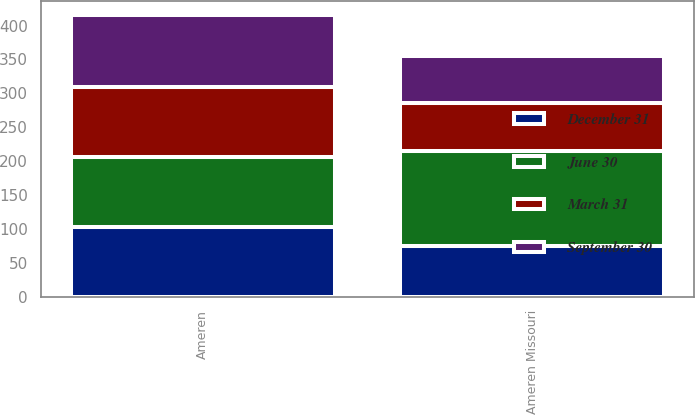<chart> <loc_0><loc_0><loc_500><loc_500><stacked_bar_chart><ecel><fcel>Ameren Missouri<fcel>Ameren<nl><fcel>September 30<fcel>70<fcel>107<nl><fcel>December 31<fcel>75<fcel>103<nl><fcel>March 31<fcel>70<fcel>103<nl><fcel>June 30<fcel>140<fcel>103<nl></chart> 